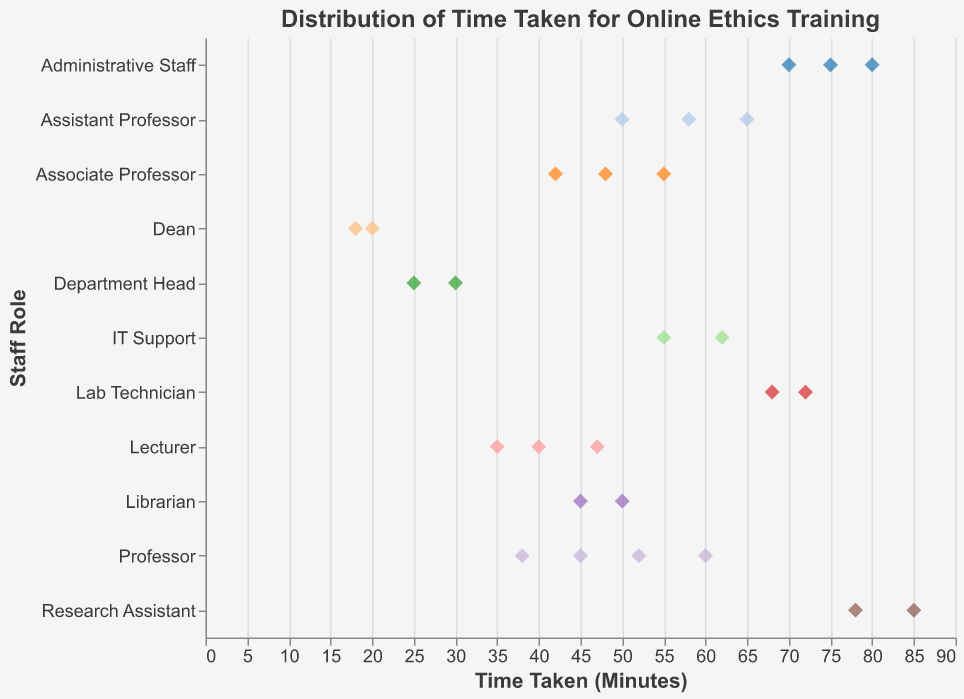What's the title of the strip plot? The title of the strip plot is located at the top of the figure. It is designed to summarize the content depicted in the visual.
Answer: Distribution of Time Taken for Online Ethics Training Which staff role took the longest time to complete the training? To determine the longest time taken, look for the data point with the greatest x-value (Time Taken in Minutes). Identify the corresponding role on the y-axis.
Answer: Research Assistant How many minutes did the Dean take on average to complete the training? There are two data points for the Dean role: 20 and 18 minutes. To find the average, add these times and divide by the number of observations. \( (20 + 18) / 2 = 19 \)
Answer: 19 Which role has the lowest average time spent on training? Calculate the average time for each role, then identify the role with the lowest average. The Dean has an average of \( ((20 + 18) / 2) = 19 \) minutes.
Answer: Dean What's the difference between the maximum time taken by the Research Assistants and the Administrative Staff? The maximum time taken by Research Assistants is 85 minutes, while for Administrative Staff, it is 80 minutes. Subtract the higher from the lower value. \( 85 - 80 = 5 \)
Answer: 5 Which role has the most variation in the time taken for training? The role with the greatest spread (range) between data points on the x-axis has the most variation. Calculate the range for each role and identify the role with the largest range. Research Assistants have a range from 78 to 85 (85 - 78 = 7), and Administrative Staff have a range from 70 to 80 (80 - 70 = 10).
Answer: Administrative Staff What's the median time taken by Professors to complete the training? To find the median, sort the time taken values for Professors: 38, 45, 52, 60. With an even number of observations, the median is the average of the two middle values. (45 + 52) / 2 = 48.5
Answer: 48.5 Which roles have data points below 30 minutes? Identify the data points on the x-axis that are less than 30 minutes and note the corresponding roles on the y-axis. Department Head and Dean have such data points.
Answer: Department Head, Dean What is the range of time taken by Associate Professors? Find the minimum and maximum times for Associate Professors and calculate the range. Minimum: 42, Maximum: 55. Range is \( 55 - 42 = 13 \)
Answer: 13 Do any staff roles take more than 60 minutes on average for the training? Calculate the average time for each role and determine if any are greater than 60 minutes. Administrative Staff have an average of (70 + 80 + 75) / 3 = 75.
Answer: Yes, Administrative Staff 